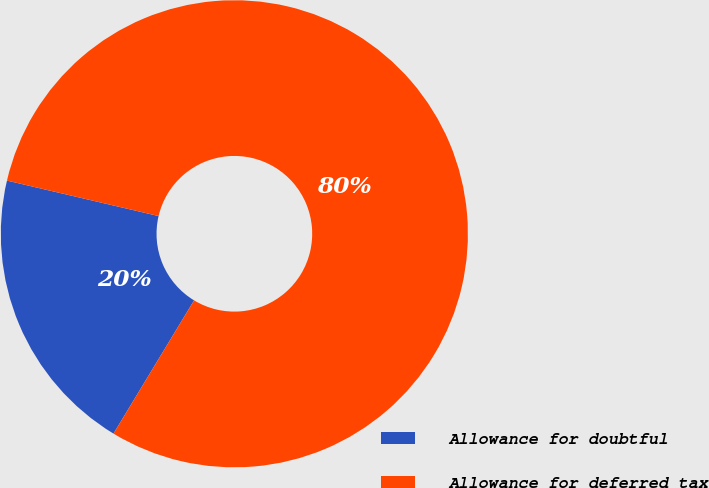Convert chart. <chart><loc_0><loc_0><loc_500><loc_500><pie_chart><fcel>Allowance for doubtful<fcel>Allowance for deferred tax<nl><fcel>20.0%<fcel>80.0%<nl></chart> 